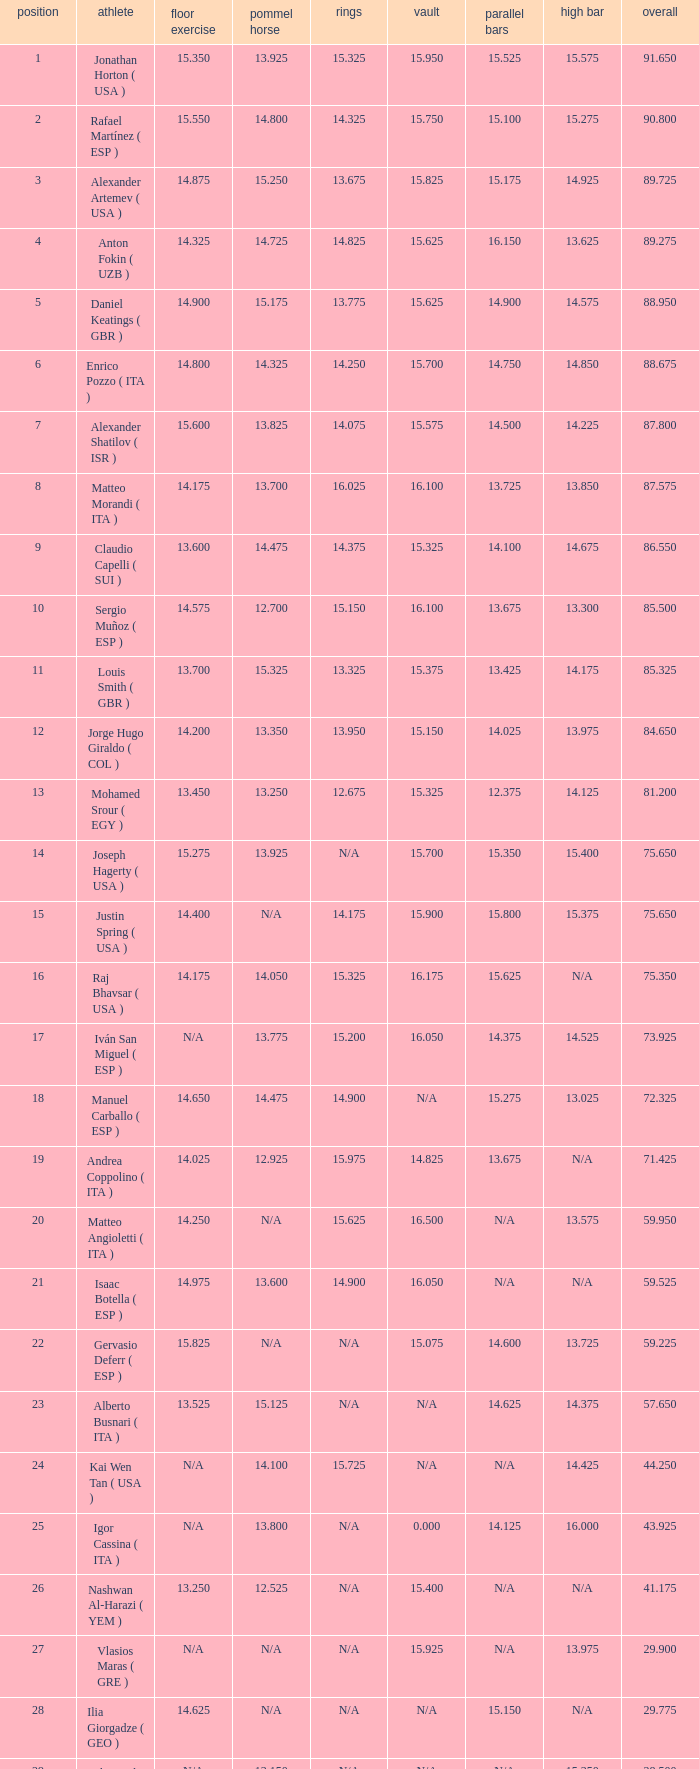150, who is the gymnast? Anton Fokin ( UZB ). 